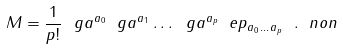<formula> <loc_0><loc_0><loc_500><loc_500>M = \frac { 1 } { p ! } \ g a ^ { a _ { 0 } } \ g a ^ { a _ { 1 } } \dots \ g a ^ { a _ { p } } \ e p _ { a _ { 0 } \dots a _ { p } } \ . \ n o n</formula> 